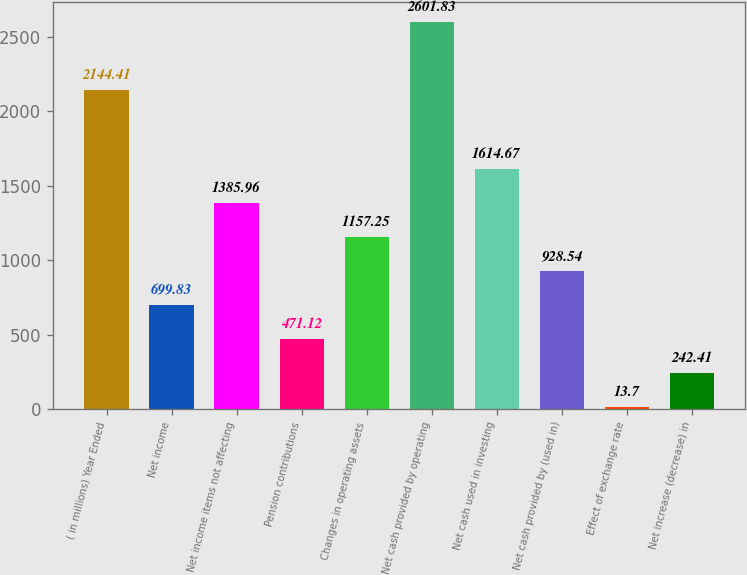<chart> <loc_0><loc_0><loc_500><loc_500><bar_chart><fcel>( in millions) Year Ended<fcel>Net income<fcel>Net income items not affecting<fcel>Pension contributions<fcel>Changes in operating assets<fcel>Net cash provided by operating<fcel>Net cash used in investing<fcel>Net cash provided by (used in)<fcel>Effect of exchange rate<fcel>Net increase (decrease) in<nl><fcel>2144.41<fcel>699.83<fcel>1385.96<fcel>471.12<fcel>1157.25<fcel>2601.83<fcel>1614.67<fcel>928.54<fcel>13.7<fcel>242.41<nl></chart> 